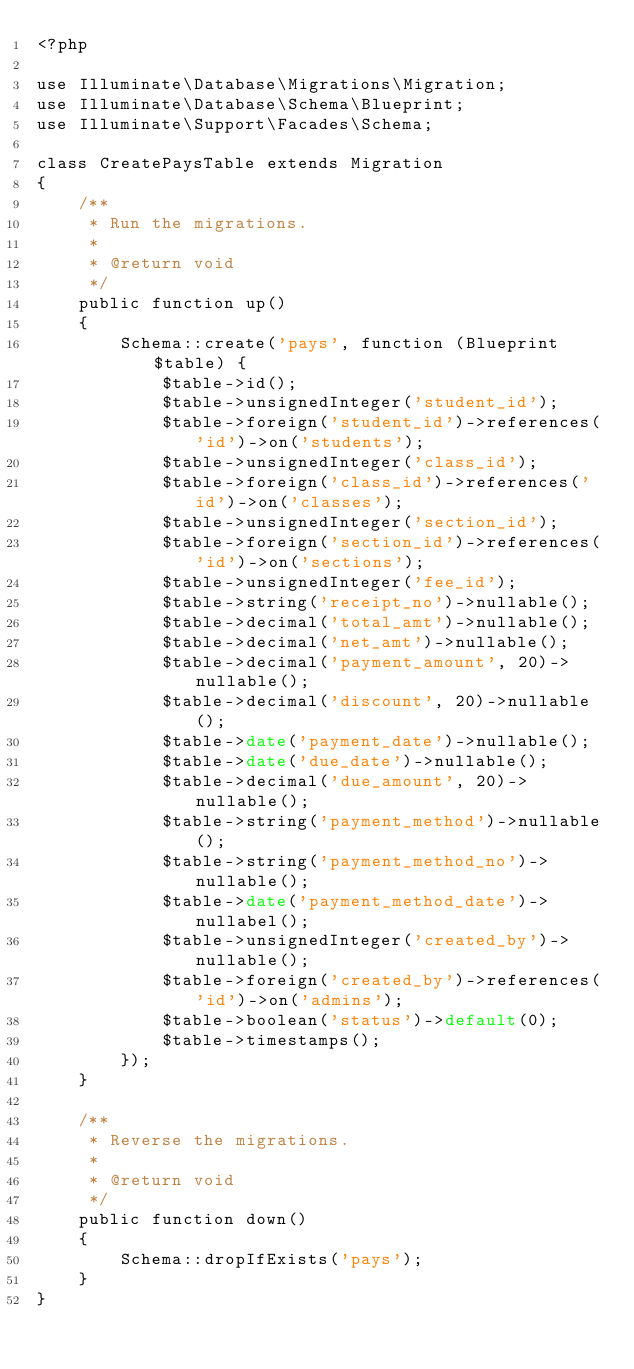Convert code to text. <code><loc_0><loc_0><loc_500><loc_500><_PHP_><?php

use Illuminate\Database\Migrations\Migration;
use Illuminate\Database\Schema\Blueprint;
use Illuminate\Support\Facades\Schema;

class CreatePaysTable extends Migration
{
    /**
     * Run the migrations.
     *
     * @return void
     */
    public function up()
    {
        Schema::create('pays', function (Blueprint $table) {
            $table->id();
            $table->unsignedInteger('student_id');
            $table->foreign('student_id')->references('id')->on('students');
            $table->unsignedInteger('class_id');
            $table->foreign('class_id')->references('id')->on('classes');
            $table->unsignedInteger('section_id');
            $table->foreign('section_id')->references('id')->on('sections');
            $table->unsignedInteger('fee_id');
            $table->string('receipt_no')->nullable();
            $table->decimal('total_amt')->nullable();
            $table->decimal('net_amt')->nullable();
            $table->decimal('payment_amount', 20)->nullable();
            $table->decimal('discount', 20)->nullable();
            $table->date('payment_date')->nullable();
            $table->date('due_date')->nullable();
            $table->decimal('due_amount', 20)->nullable();
            $table->string('payment_method')->nullable();
            $table->string('payment_method_no')->nullable();
            $table->date('payment_method_date')->nullabel();
            $table->unsignedInteger('created_by')->nullable();
            $table->foreign('created_by')->references('id')->on('admins');
            $table->boolean('status')->default(0);
            $table->timestamps();
        });
    }

    /**
     * Reverse the migrations.
     *
     * @return void
     */
    public function down()
    {
        Schema::dropIfExists('pays');
    }
}
</code> 